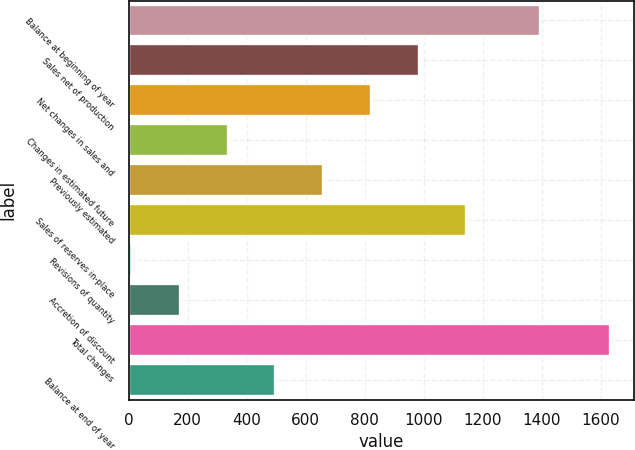Convert chart. <chart><loc_0><loc_0><loc_500><loc_500><bar_chart><fcel>Balance at beginning of year<fcel>Sales net of production<fcel>Net changes in sales and<fcel>Changes in estimated future<fcel>Previously estimated<fcel>Sales of reserves in-place<fcel>Revisions of quantity<fcel>Accretion of discount<fcel>Total changes<fcel>Balance at end of year<nl><fcel>1392<fcel>982.2<fcel>820.5<fcel>335.4<fcel>658.8<fcel>1143.9<fcel>12<fcel>173.7<fcel>1629<fcel>497.1<nl></chart> 